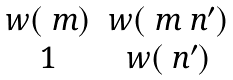<formula> <loc_0><loc_0><loc_500><loc_500>\begin{matrix} w ( \ m ) & w ( \ m \ n ^ { \prime } ) \\ 1 & w ( \ n ^ { \prime } ) \end{matrix}</formula> 